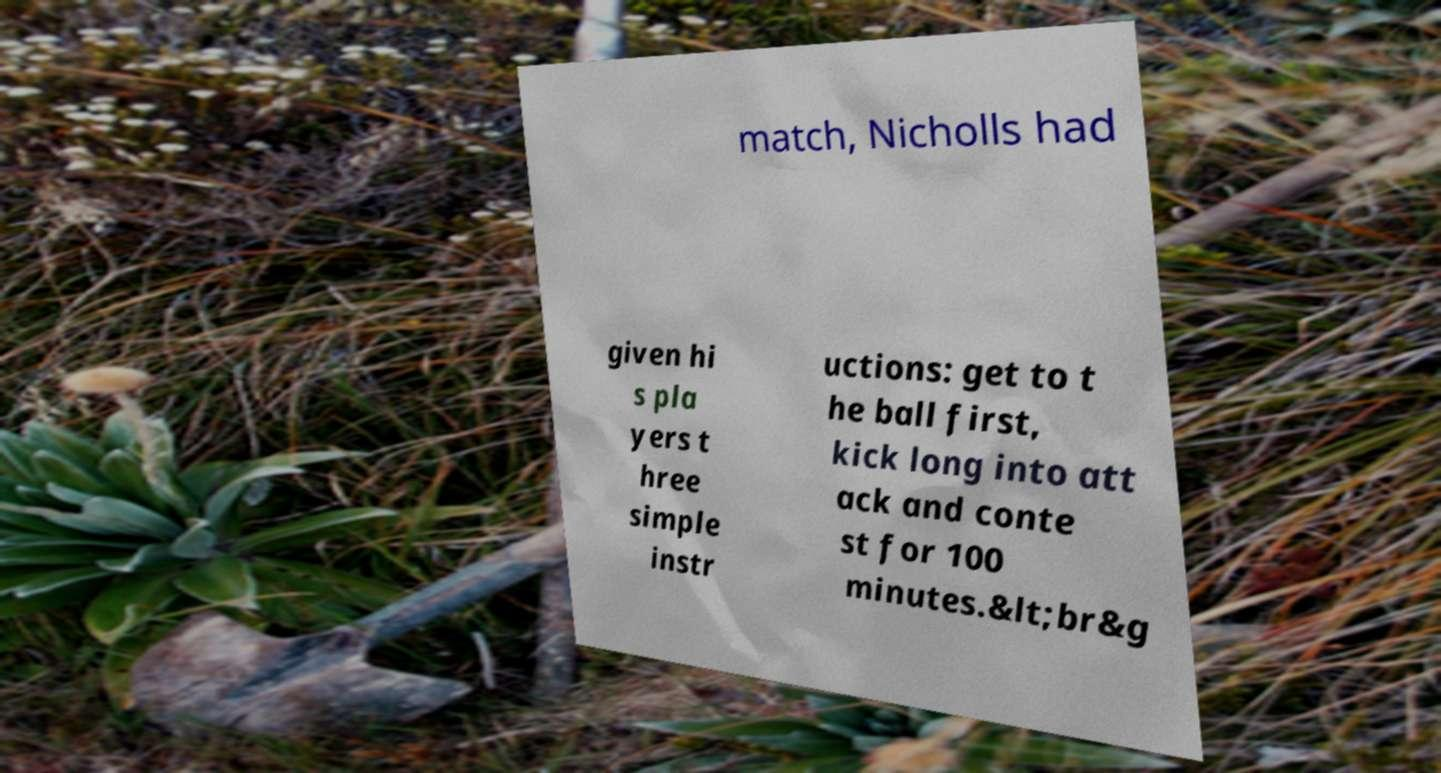There's text embedded in this image that I need extracted. Can you transcribe it verbatim? match, Nicholls had given hi s pla yers t hree simple instr uctions: get to t he ball first, kick long into att ack and conte st for 100 minutes.&lt;br&g 